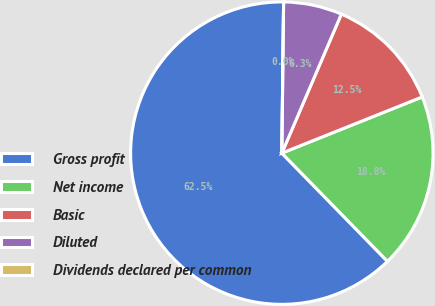<chart> <loc_0><loc_0><loc_500><loc_500><pie_chart><fcel>Gross profit<fcel>Net income<fcel>Basic<fcel>Diluted<fcel>Dividends declared per common<nl><fcel>62.49%<fcel>18.75%<fcel>12.5%<fcel>6.25%<fcel>0.0%<nl></chart> 